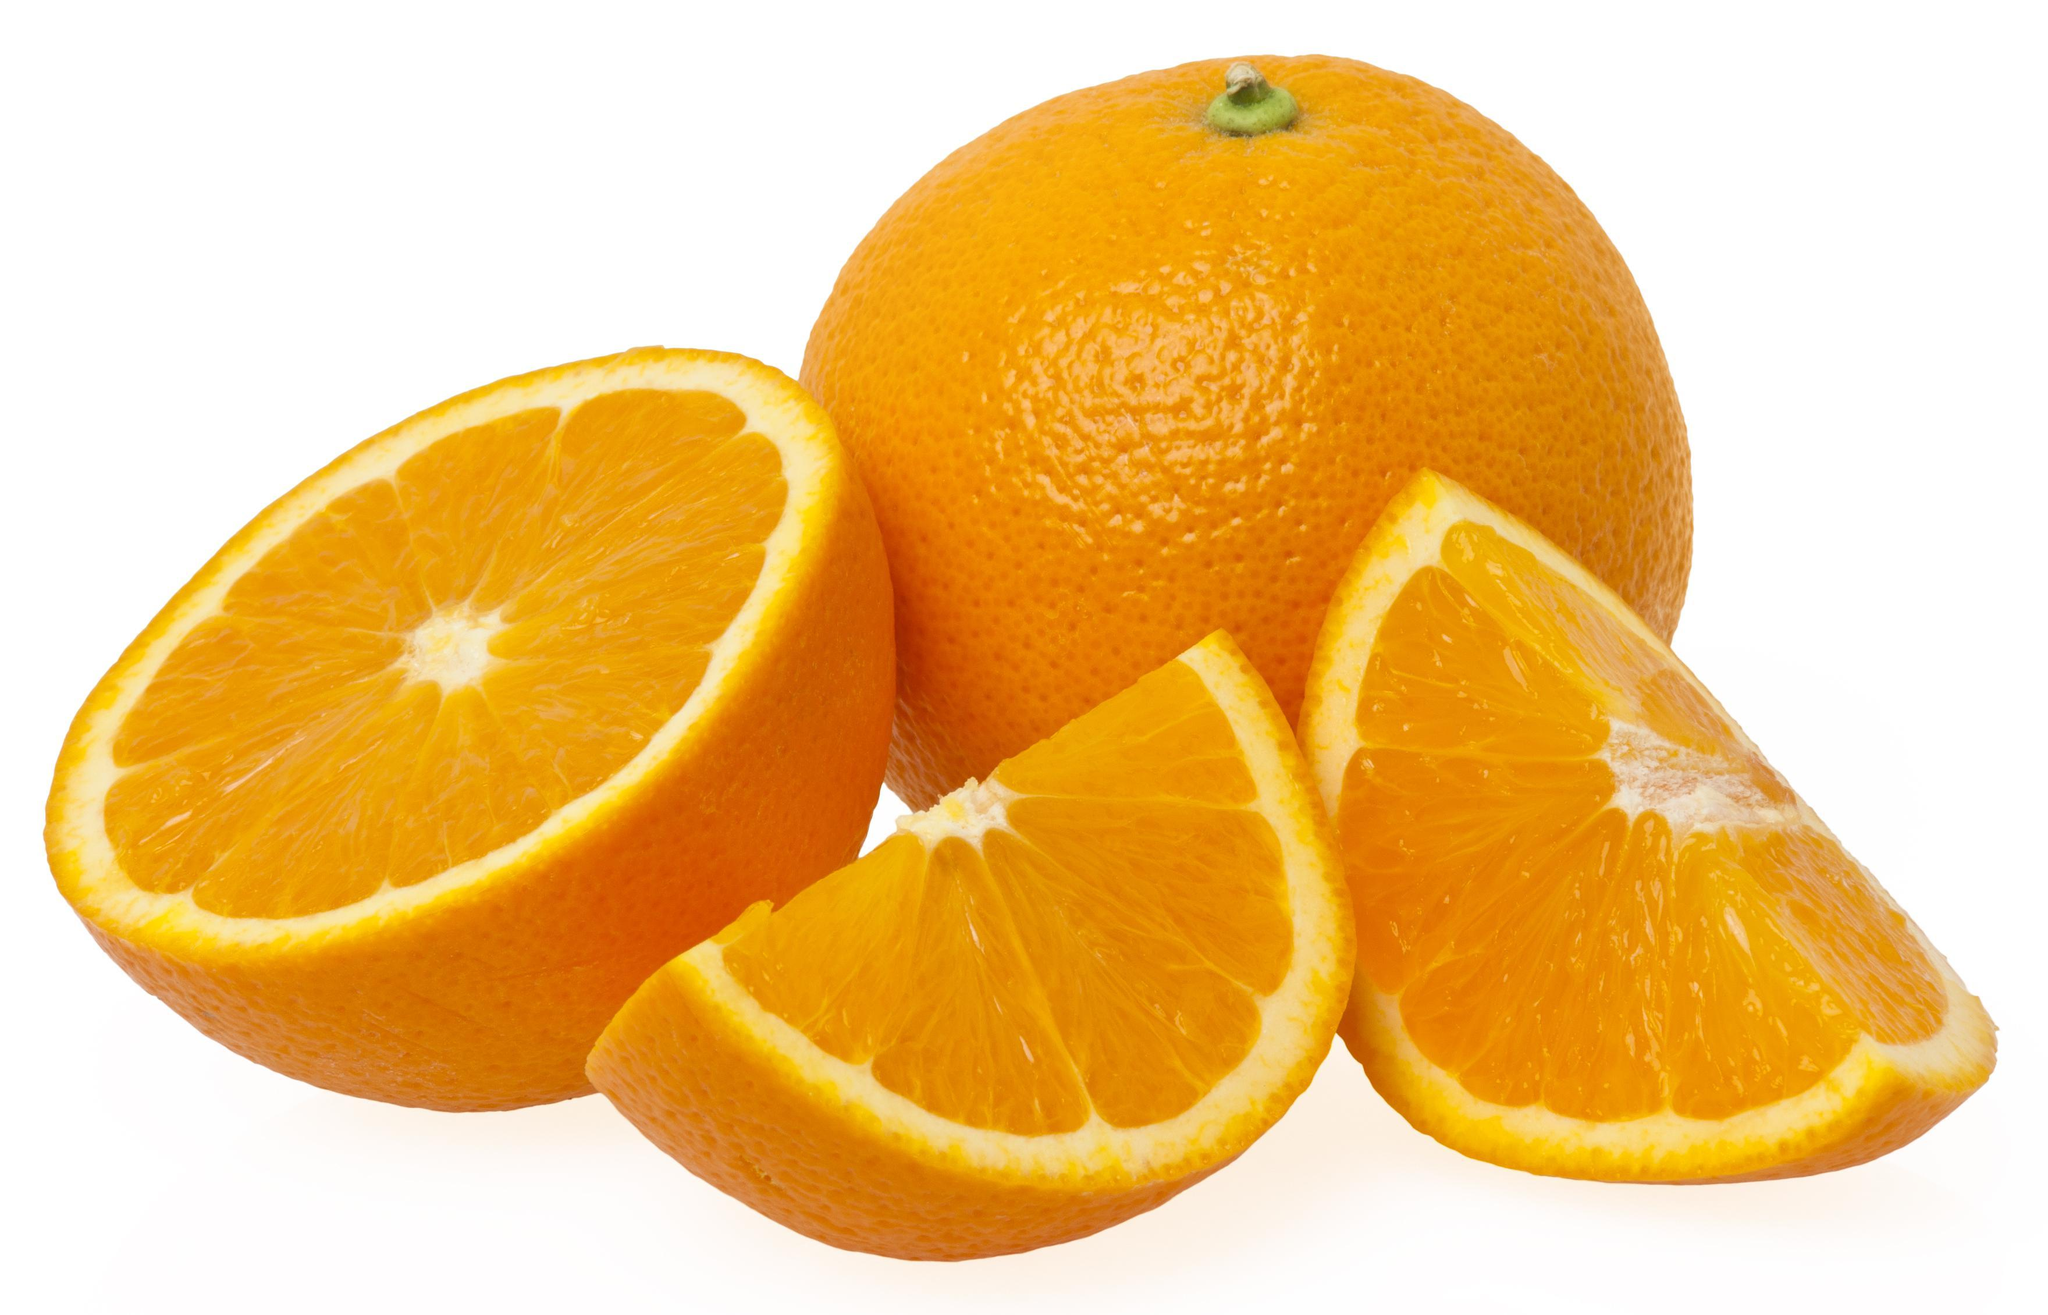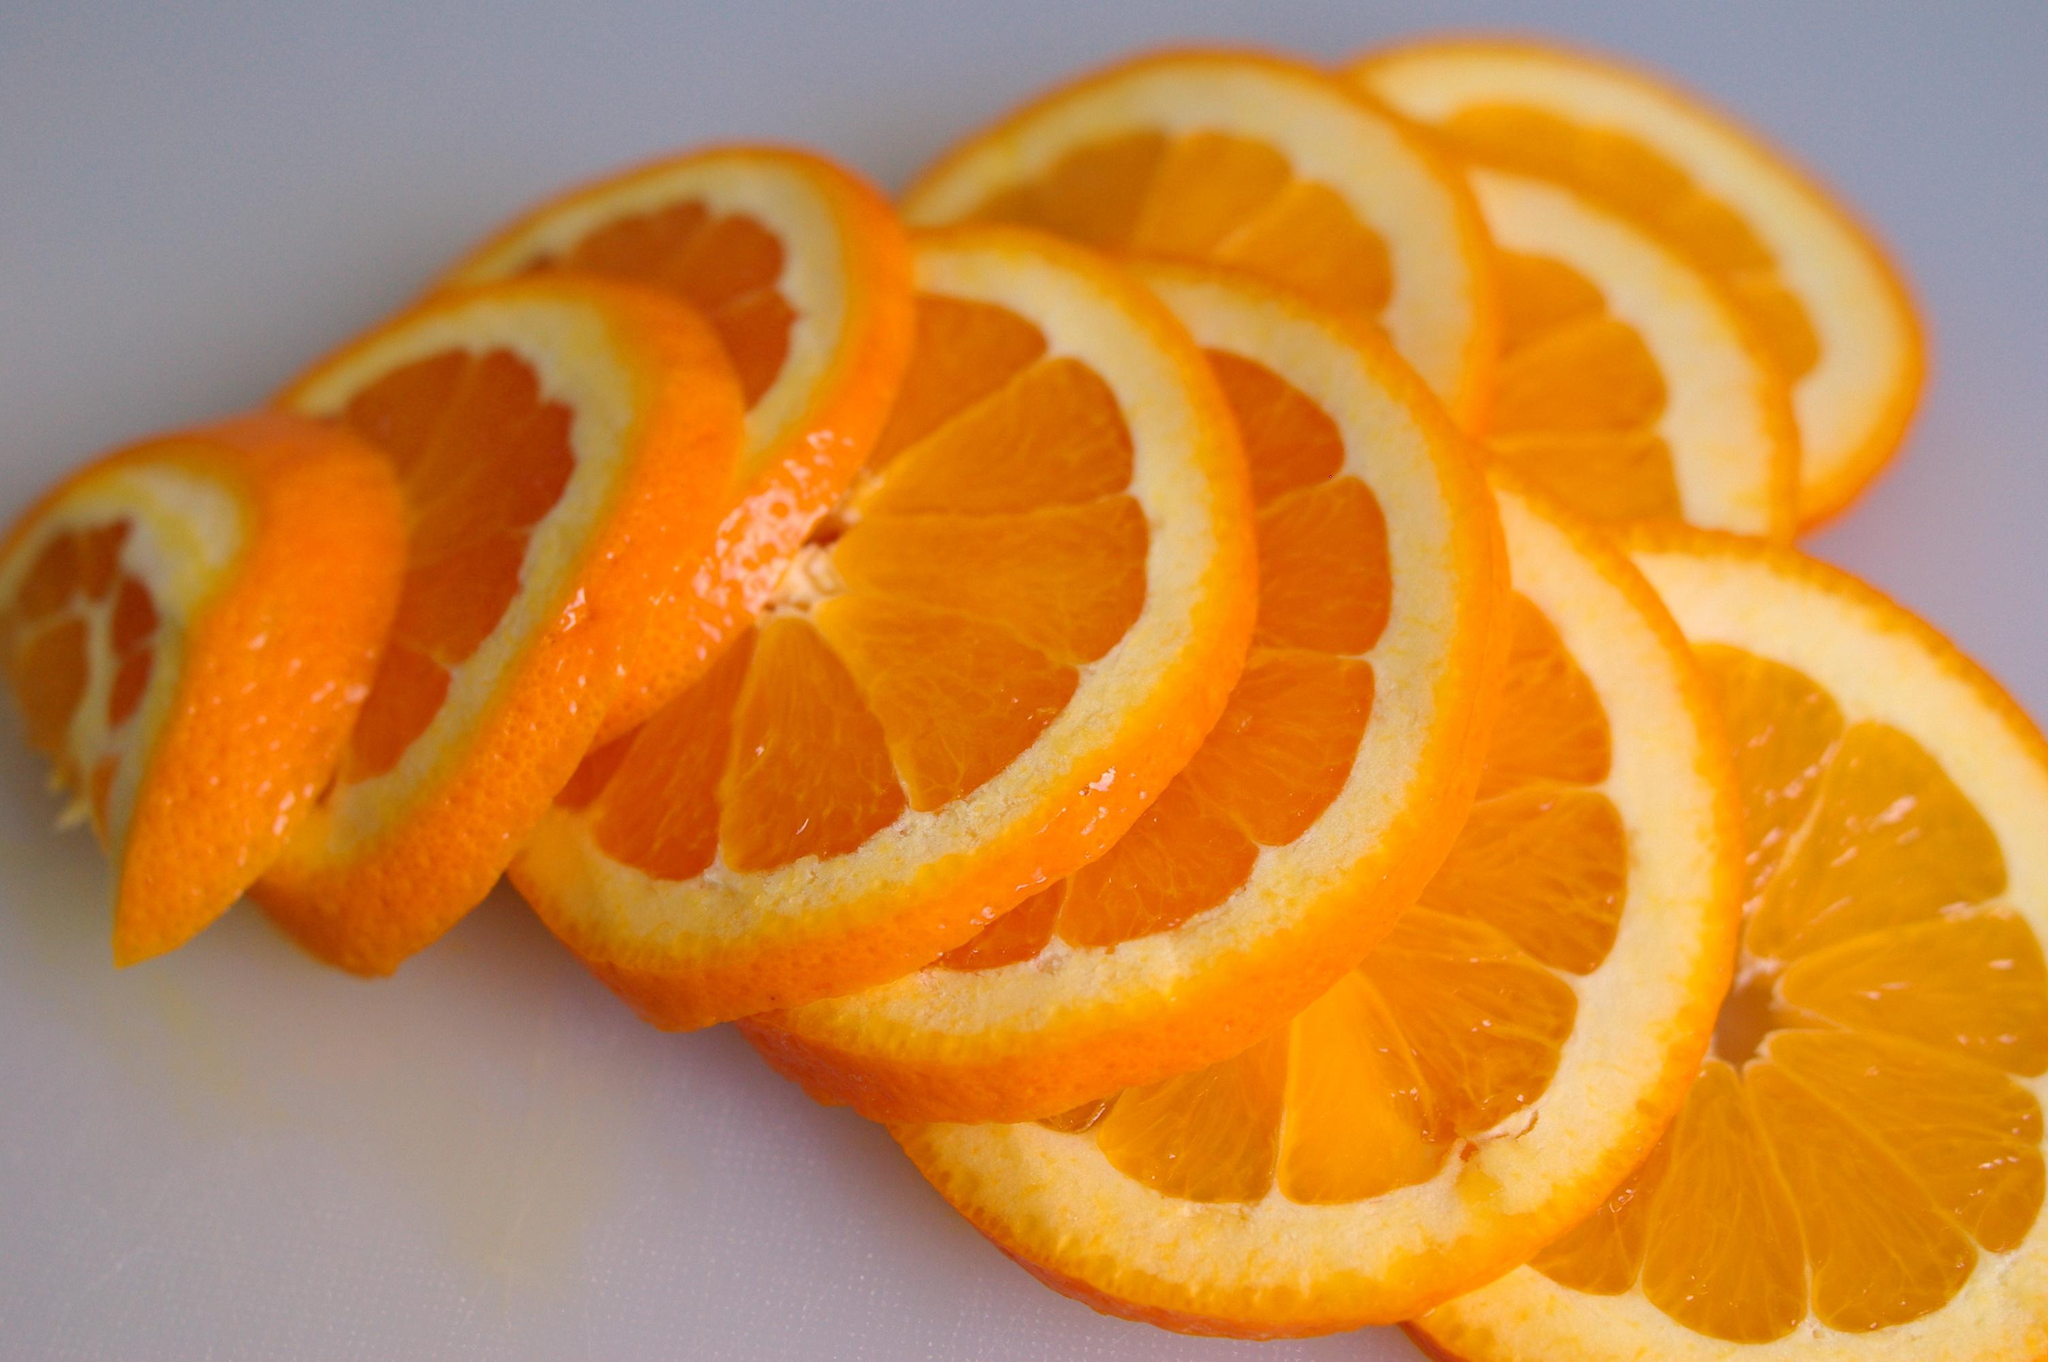The first image is the image on the left, the second image is the image on the right. Assess this claim about the two images: "There is one whole uncut orange in the left image.". Correct or not? Answer yes or no. Yes. The first image is the image on the left, the second image is the image on the right. Evaluate the accuracy of this statement regarding the images: "The left image contains at least one orange wedge and nothing else, and the right image contains at least one orange slice and nothing else.". Is it true? Answer yes or no. No. 